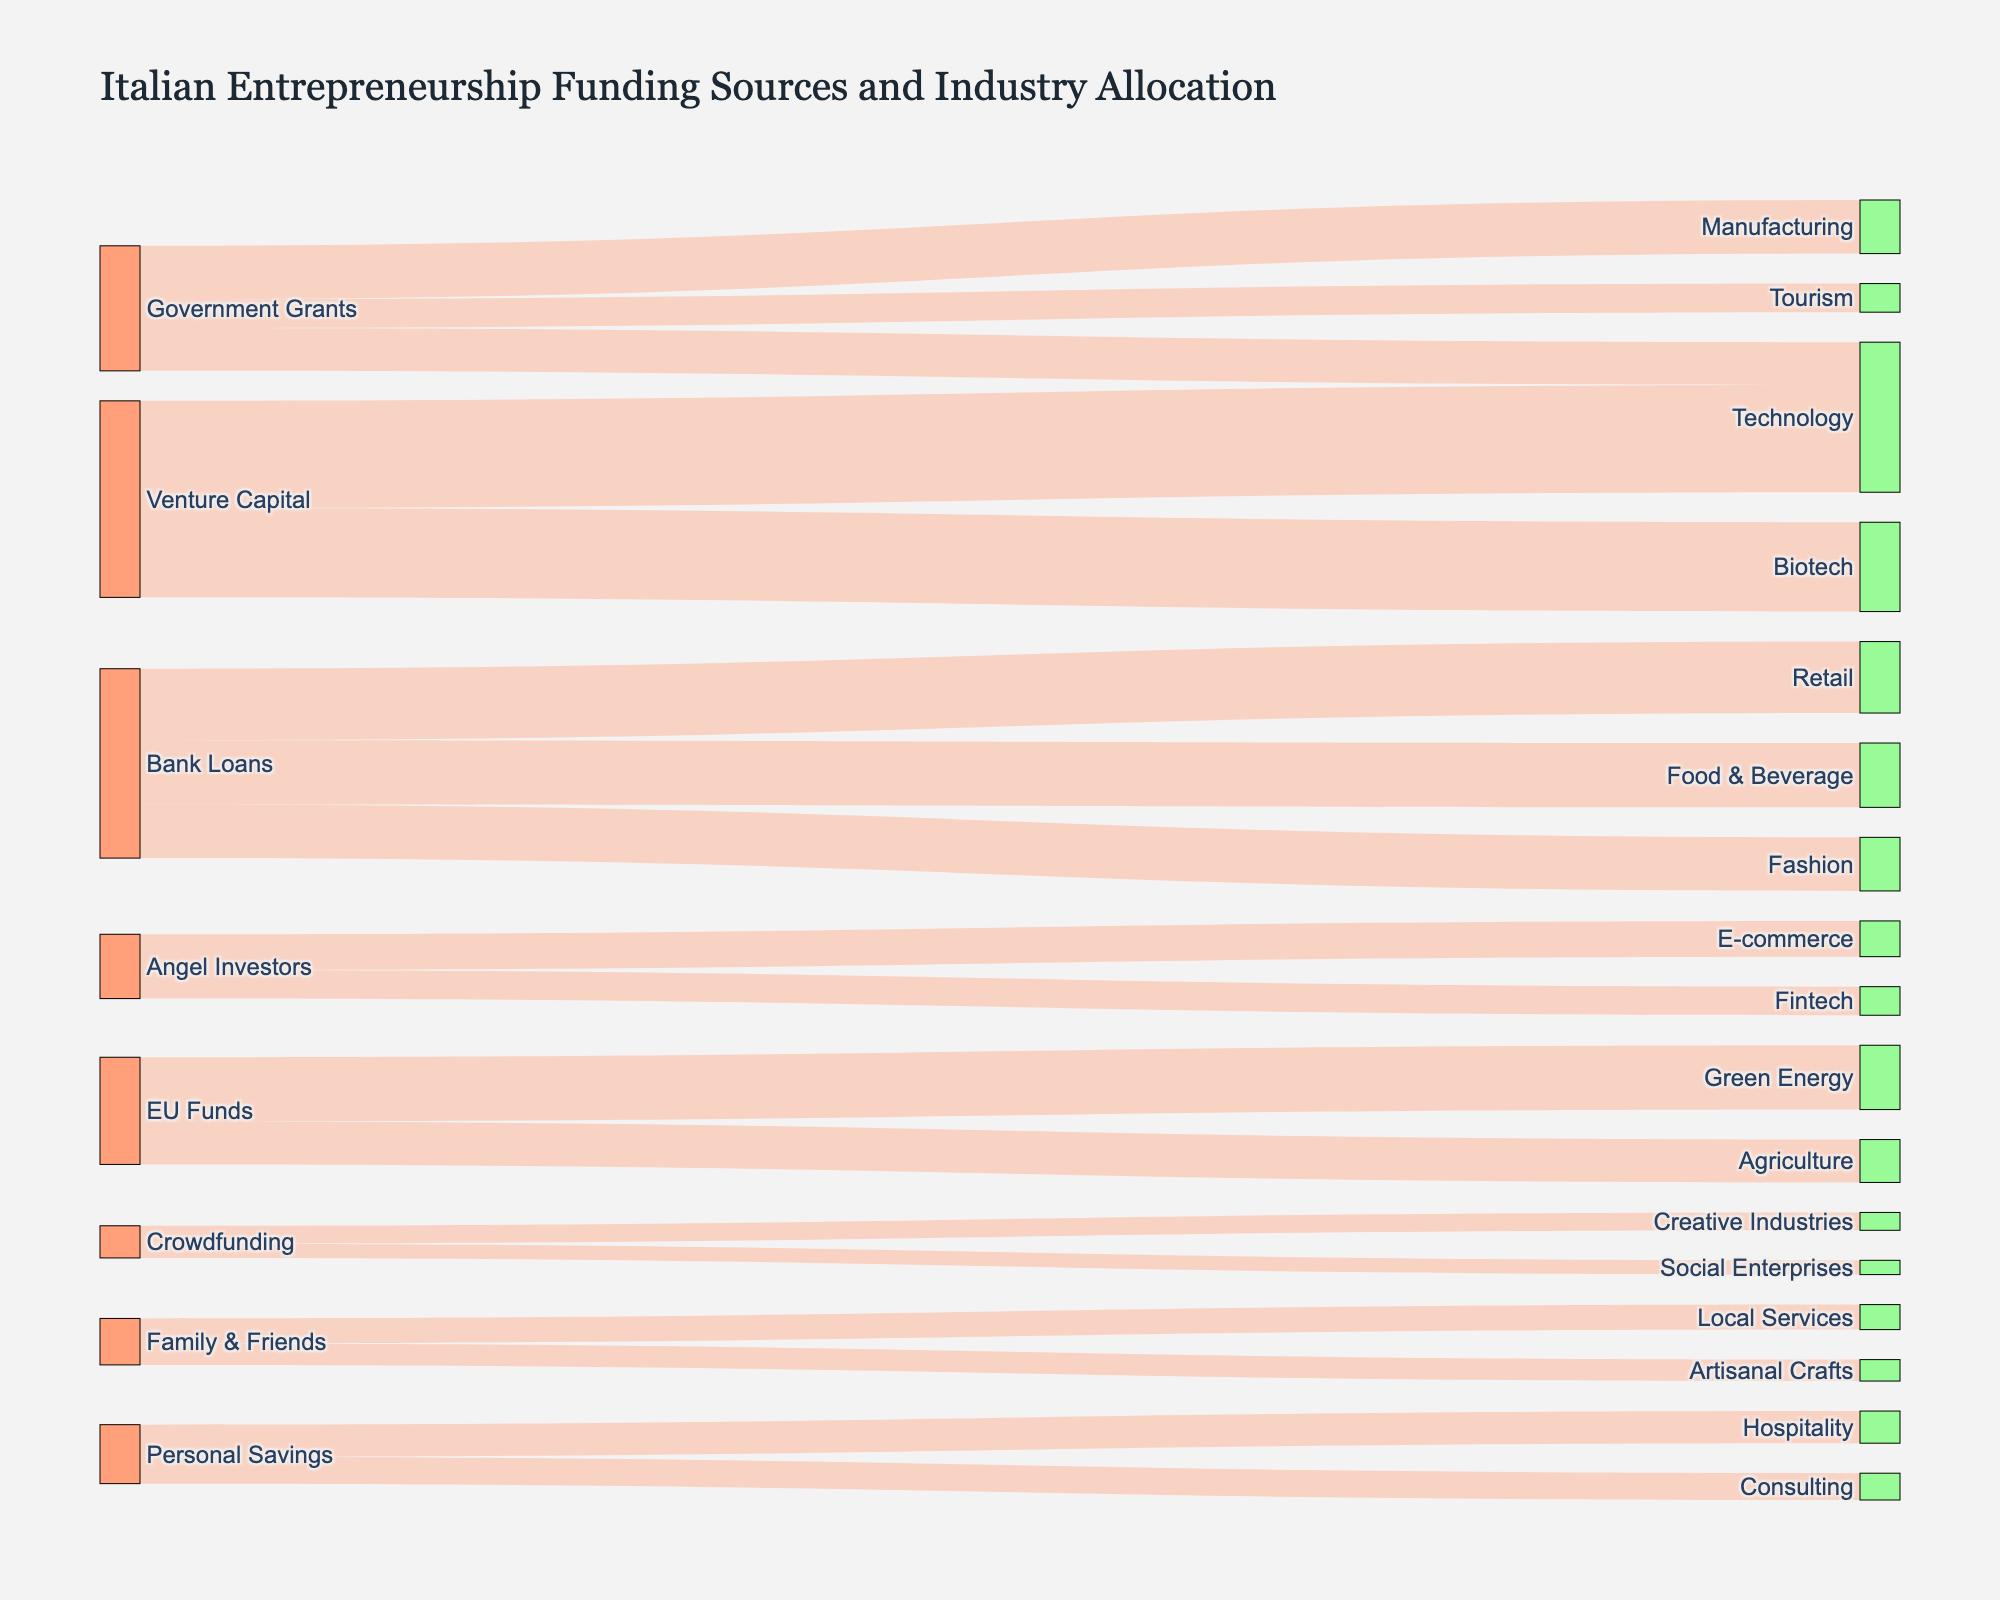What is the total amount allocated to the Technology industry from all funding sources? To find the total allocation to Technology, sum the values of all funding sources targeted at the Technology industry. According to the diagram, Technology receives 120 units from Government Grants and 300 units from Venture Capital. The total is 120 + 300 = 420.
Answer: 420 Which source contributes the most funding to a single industry? Compare all the funding contributions from each source to various industries. The highest contribution noted in the figure is from Venture Capital to Technology, which is 300 units, the largest single contribution.
Answer: Venture Capital How many different funding sources are displayed in the diagram? To determine the number of funding sources, count the unique elements in the "source" category. There are: Government Grants, Bank Loans, Venture Capital, Angel Investors, EU Funds, Crowdfunding, Family & Friends, and Personal Savings. Thus, there are 8 sources.
Answer: 8 What is the smallest funding allocation and which industry receives it? Examine each funding allocation to identify the smallest value. The smallest allocation shown in the figure is from Crowdfunding to Social Enterprises, which is 40 units.
Answer: 40 How does the allocation to Green Energy compare to the allocation to Agriculture from EU Funds? Identify the funds allocated to Green Energy and Agriculture from EU Funds. Green Energy receives 180 units, and Agriculture receives 120 units from EU Funds. Consequently, Green Energy receives more funding.
Answer: Green Energy What's the combined funding received by the Tourism and Hospitality industries? Add the amounts received by Tourism and Hospitality industries. Tourism receives 80 units from Government Grants, and Hospitality receives 90 units from Personal Savings. The total is 80 + 90 = 170.
Answer: 170 Which two industries receive funding from the most different sources? Determine the number of different sources funding each industry. Technology is funded by Government Grants and Venture Capital, totaling 2 sources. No industry is funded by more than 2 sources in the figure.
Answer: Technology What's the total funding received by all industries combined? Sum all the values directed towards various industries to get the total funding. The sum is 150 + 80 + 120 + 200 + 180 + 150 + 300 + 250 + 100 + 80 + 180 + 120 + 50 + 40 + 60 + 70 + 90 + 75 = 2295.
Answer: 2295 